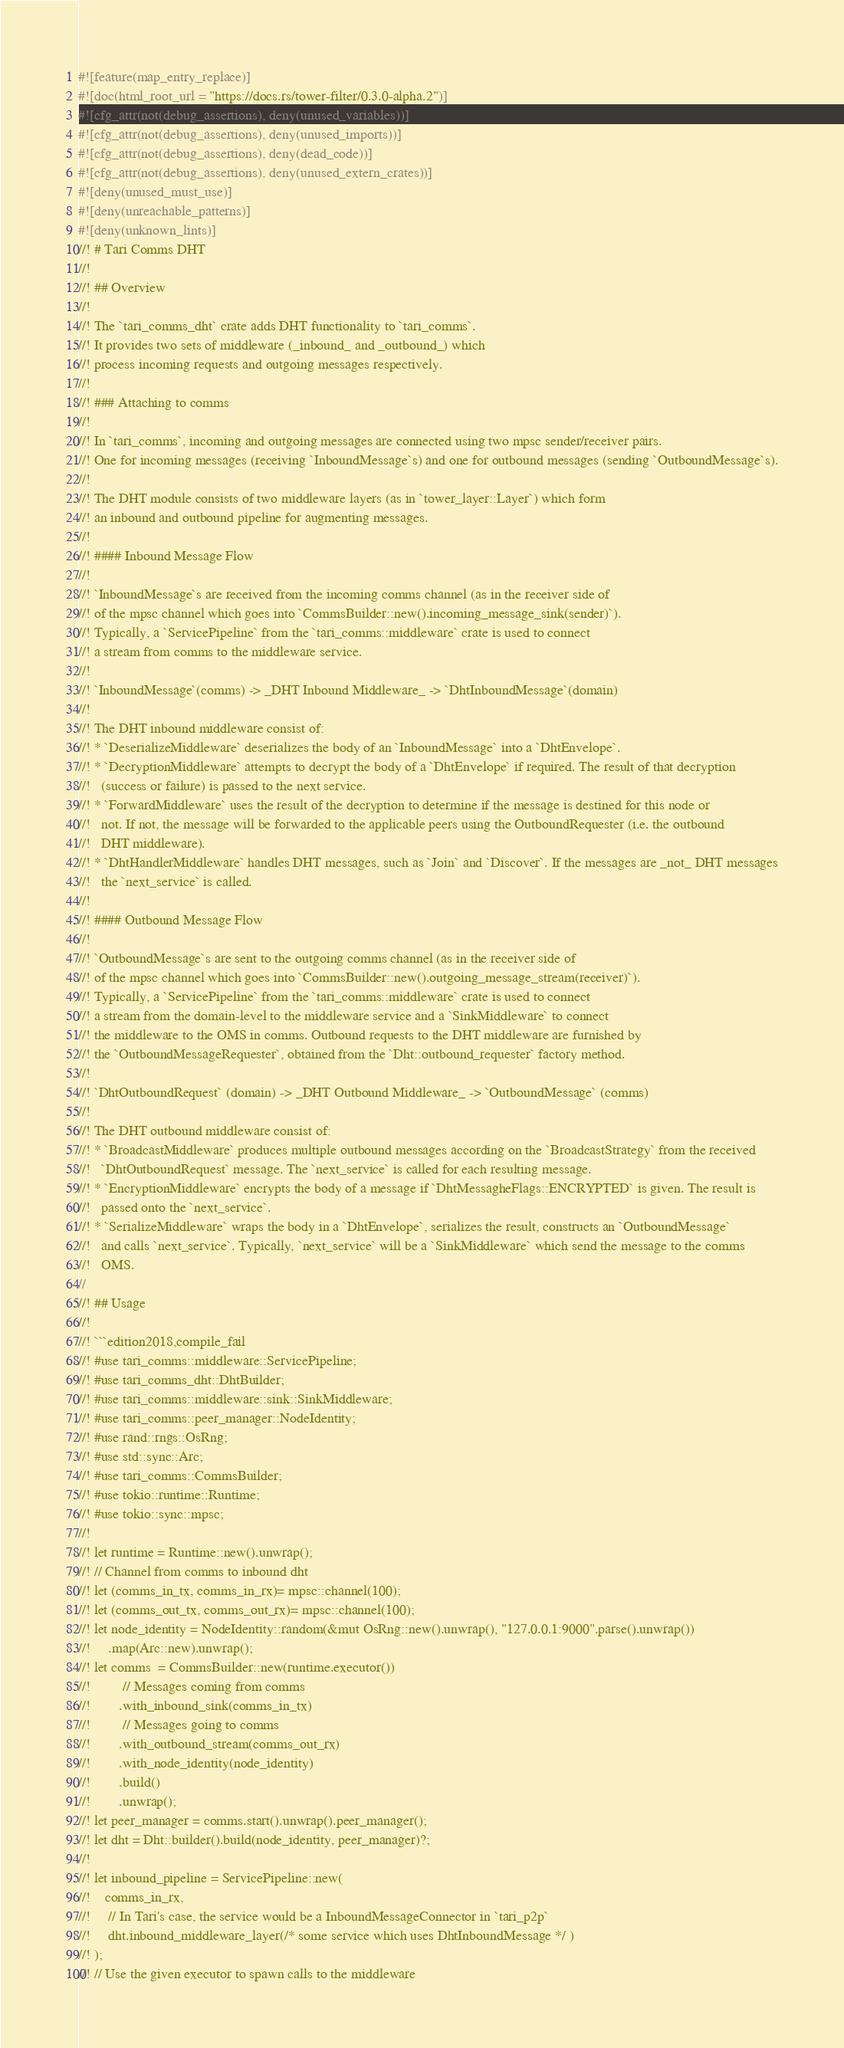Convert code to text. <code><loc_0><loc_0><loc_500><loc_500><_Rust_>#![feature(map_entry_replace)]
#![doc(html_root_url = "https://docs.rs/tower-filter/0.3.0-alpha.2")]
#![cfg_attr(not(debug_assertions), deny(unused_variables))]
#![cfg_attr(not(debug_assertions), deny(unused_imports))]
#![cfg_attr(not(debug_assertions), deny(dead_code))]
#![cfg_attr(not(debug_assertions), deny(unused_extern_crates))]
#![deny(unused_must_use)]
#![deny(unreachable_patterns)]
#![deny(unknown_lints)]
//! # Tari Comms DHT
//!
//! ## Overview
//!
//! The `tari_comms_dht` crate adds DHT functionality to `tari_comms`.
//! It provides two sets of middleware (_inbound_ and _outbound_) which
//! process incoming requests and outgoing messages respectively.
//!
//! ### Attaching to comms
//!
//! In `tari_comms`, incoming and outgoing messages are connected using two mpsc sender/receiver pairs.
//! One for incoming messages (receiving `InboundMessage`s) and one for outbound messages (sending `OutboundMessage`s).
//!
//! The DHT module consists of two middleware layers (as in `tower_layer::Layer`) which form
//! an inbound and outbound pipeline for augmenting messages.
//!
//! #### Inbound Message Flow
//!
//! `InboundMessage`s are received from the incoming comms channel (as in the receiver side of
//! of the mpsc channel which goes into `CommsBuilder::new().incoming_message_sink(sender)`).
//! Typically, a `ServicePipeline` from the `tari_comms::middleware` crate is used to connect
//! a stream from comms to the middleware service.
//!
//! `InboundMessage`(comms) -> _DHT Inbound Middleware_ -> `DhtInboundMessage`(domain)
//!
//! The DHT inbound middleware consist of:
//! * `DeserializeMiddleware` deserializes the body of an `InboundMessage` into a `DhtEnvelope`.
//! * `DecryptionMiddleware` attempts to decrypt the body of a `DhtEnvelope` if required. The result of that decryption
//!   (success or failure) is passed to the next service.
//! * `ForwardMiddleware` uses the result of the decryption to determine if the message is destined for this node or
//!   not. If not, the message will be forwarded to the applicable peers using the OutboundRequester (i.e. the outbound
//!   DHT middleware).
//! * `DhtHandlerMiddleware` handles DHT messages, such as `Join` and `Discover`. If the messages are _not_ DHT messages
//!   the `next_service` is called.
//!
//! #### Outbound Message Flow
//!
//! `OutboundMessage`s are sent to the outgoing comms channel (as in the receiver side of
//! of the mpsc channel which goes into `CommsBuilder::new().outgoing_message_stream(receiver)`).
//! Typically, a `ServicePipeline` from the `tari_comms::middleware` crate is used to connect
//! a stream from the domain-level to the middleware service and a `SinkMiddleware` to connect
//! the middleware to the OMS in comms. Outbound requests to the DHT middleware are furnished by
//! the `OutboundMessageRequester`, obtained from the `Dht::outbound_requester` factory method.
//!
//! `DhtOutboundRequest` (domain) -> _DHT Outbound Middleware_ -> `OutboundMessage` (comms)
//!
//! The DHT outbound middleware consist of:
//! * `BroadcastMiddleware` produces multiple outbound messages according on the `BroadcastStrategy` from the received
//!   `DhtOutboundRequest` message. The `next_service` is called for each resulting message.
//! * `EncryptionMiddleware` encrypts the body of a message if `DhtMessagheFlags::ENCRYPTED` is given. The result is
//!   passed onto the `next_service`.
//! * `SerializeMiddleware` wraps the body in a `DhtEnvelope`, serializes the result, constructs an `OutboundMessage`
//!   and calls `next_service`. Typically, `next_service` will be a `SinkMiddleware` which send the message to the comms
//!   OMS.
//
//! ## Usage
//!
//! ```edition2018,compile_fail
//! #use tari_comms::middleware::ServicePipeline;
//! #use tari_comms_dht::DhtBuilder;
//! #use tari_comms::middleware::sink::SinkMiddleware;
//! #use tari_comms::peer_manager::NodeIdentity;
//! #use rand::rngs::OsRng;
//! #use std::sync::Arc;
//! #use tari_comms::CommsBuilder;
//! #use tokio::runtime::Runtime;
//! #use tokio::sync::mpsc;
//!
//! let runtime = Runtime::new().unwrap();
//! // Channel from comms to inbound dht
//! let (comms_in_tx, comms_in_rx)= mpsc::channel(100);
//! let (comms_out_tx, comms_out_rx)= mpsc::channel(100);
//! let node_identity = NodeIdentity::random(&mut OsRng::new().unwrap(), "127.0.0.1:9000".parse().unwrap())
//!     .map(Arc::new).unwrap();
//! let comms  = CommsBuilder::new(runtime.executor())
//!         // Messages coming from comms
//!        .with_inbound_sink(comms_in_tx)
//!         // Messages going to comms
//!        .with_outbound_stream(comms_out_rx)
//!        .with_node_identity(node_identity)
//!        .build()
//!        .unwrap();
//! let peer_manager = comms.start().unwrap().peer_manager();
//! let dht = Dht::builder().build(node_identity, peer_manager)?;
//!
//! let inbound_pipeline = ServicePipeline::new(
//!    comms_in_rx,
//!     // In Tari's case, the service would be a InboundMessageConnector in `tari_p2p`
//!     dht.inbound_middleware_layer(/* some service which uses DhtInboundMessage */ )
//! );
//! // Use the given executor to spawn calls to the middleware</code> 